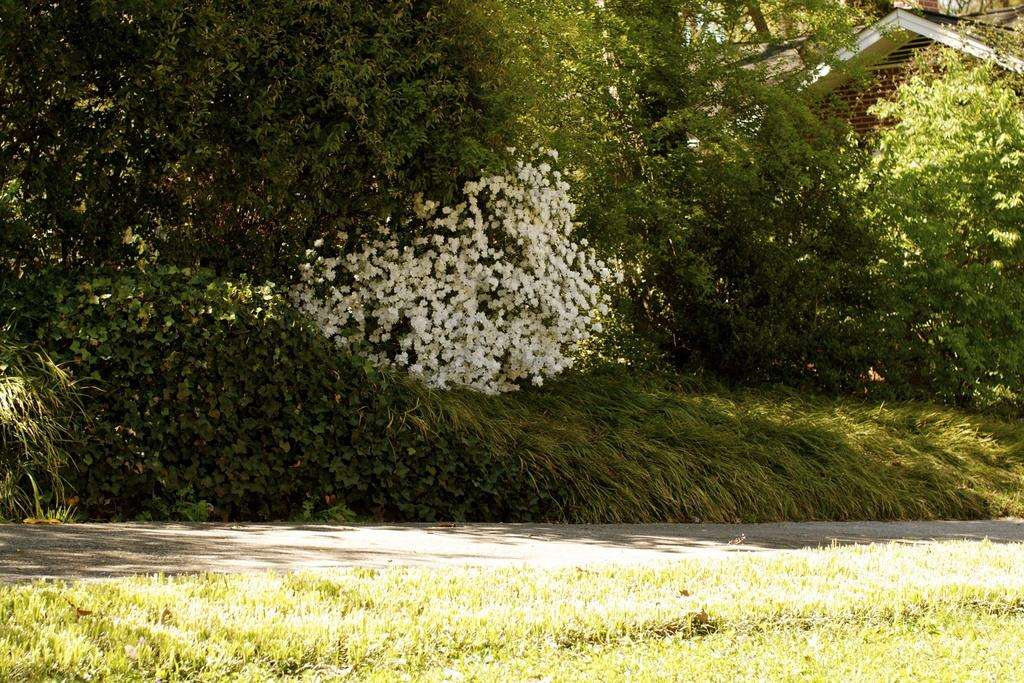What can be seen in the foreground of the image? There is a road and grass in the foreground of the image. What type of natural elements are visible in the image? Trees and plants are visible in the image. Where is the building located in the image? The building is in the right top corner of the image. What type of suit is the ground wearing in the image? There is no person or suit present in the image; it features a road, grass, trees, plants, and a building. 